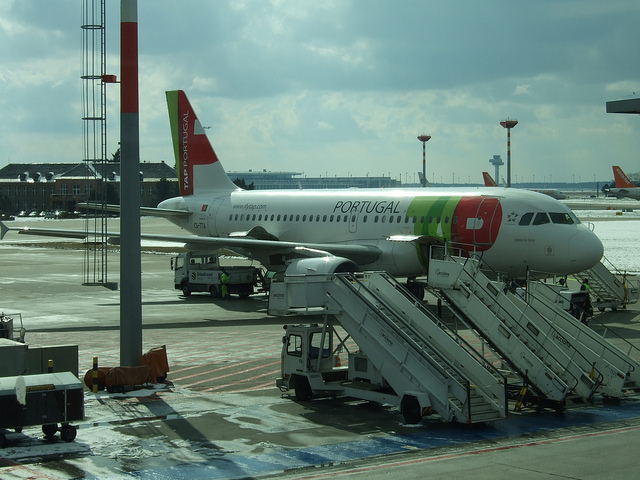Please extract the text content from this image. PORTUGAL 